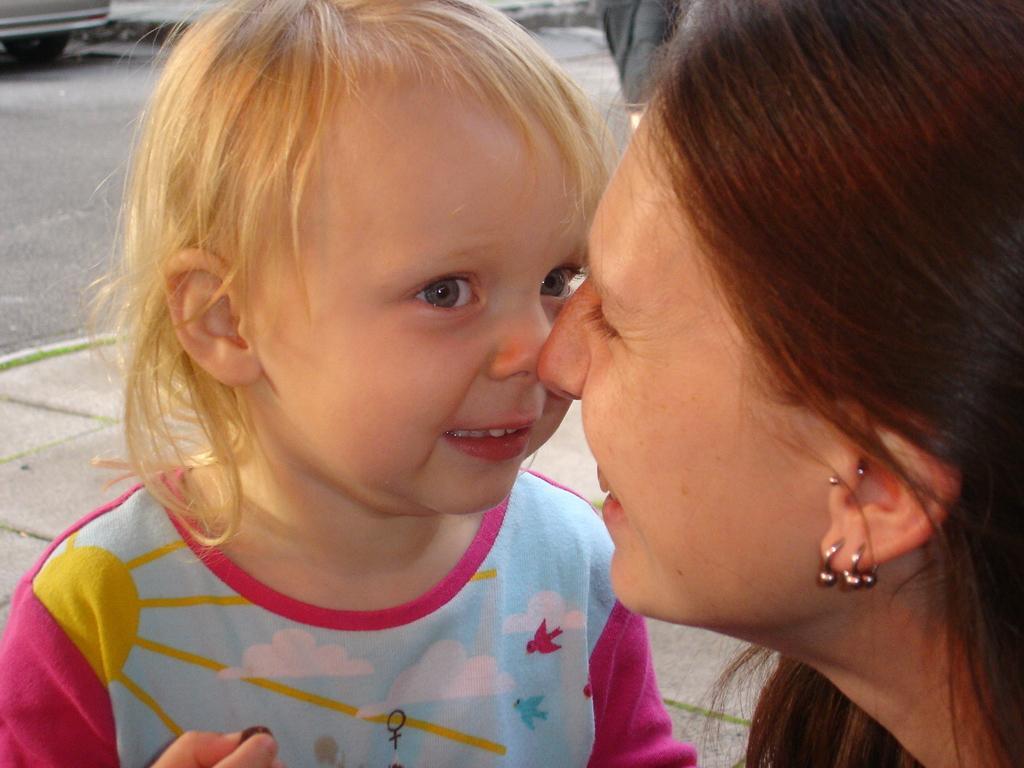Please provide a concise description of this image. In this picture there is a woman and there is a kid with pink and blue t-shirt and there is a picture of sun, clouds, sky and birds on the t-shirt. At the back there is a vehicle on the road and there is a footpath. 